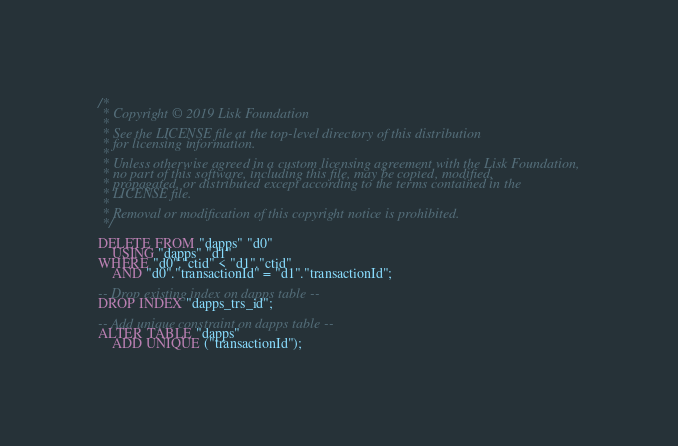Convert code to text. <code><loc_0><loc_0><loc_500><loc_500><_SQL_>/*
 * Copyright © 2019 Lisk Foundation
 *
 * See the LICENSE file at the top-level directory of this distribution
 * for licensing information.
 *
 * Unless otherwise agreed in a custom licensing agreement with the Lisk Foundation,
 * no part of this software, including this file, may be copied, modified,
 * propagated, or distributed except according to the terms contained in the
 * LICENSE file.
 *
 * Removal or modification of this copyright notice is prohibited.
 */

DELETE FROM "dapps" "d0"
	USING "dapps" "d1"
WHERE "d0"."ctid" < "d1"."ctid"
	AND "d0"."transactionId" = "d1"."transactionId";

-- Drop existing index on dapps table --
DROP INDEX "dapps_trs_id";

-- Add unique constraint on dapps table --
ALTER TABLE "dapps"
	ADD UNIQUE ("transactionId");
</code> 